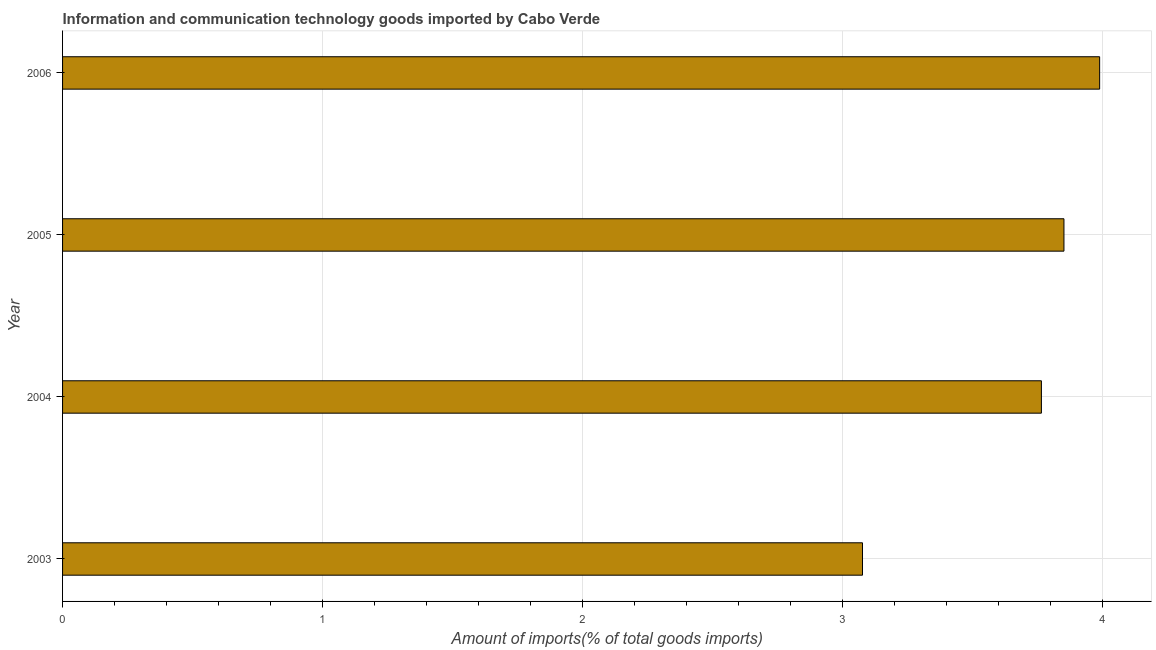Does the graph contain any zero values?
Ensure brevity in your answer.  No. What is the title of the graph?
Provide a succinct answer. Information and communication technology goods imported by Cabo Verde. What is the label or title of the X-axis?
Your answer should be compact. Amount of imports(% of total goods imports). What is the amount of ict goods imports in 2004?
Make the answer very short. 3.76. Across all years, what is the maximum amount of ict goods imports?
Provide a short and direct response. 3.99. Across all years, what is the minimum amount of ict goods imports?
Provide a short and direct response. 3.08. In which year was the amount of ict goods imports minimum?
Your response must be concise. 2003. What is the sum of the amount of ict goods imports?
Your response must be concise. 14.68. What is the difference between the amount of ict goods imports in 2003 and 2005?
Your answer should be very brief. -0.78. What is the average amount of ict goods imports per year?
Provide a succinct answer. 3.67. What is the median amount of ict goods imports?
Keep it short and to the point. 3.81. In how many years, is the amount of ict goods imports greater than 3.2 %?
Ensure brevity in your answer.  3. What is the ratio of the amount of ict goods imports in 2003 to that in 2005?
Ensure brevity in your answer.  0.8. Is the difference between the amount of ict goods imports in 2003 and 2005 greater than the difference between any two years?
Provide a short and direct response. No. What is the difference between the highest and the second highest amount of ict goods imports?
Your response must be concise. 0.14. What is the difference between the highest and the lowest amount of ict goods imports?
Make the answer very short. 0.91. Are all the bars in the graph horizontal?
Keep it short and to the point. Yes. What is the Amount of imports(% of total goods imports) of 2003?
Your response must be concise. 3.08. What is the Amount of imports(% of total goods imports) of 2004?
Give a very brief answer. 3.76. What is the Amount of imports(% of total goods imports) in 2005?
Your answer should be very brief. 3.85. What is the Amount of imports(% of total goods imports) of 2006?
Provide a succinct answer. 3.99. What is the difference between the Amount of imports(% of total goods imports) in 2003 and 2004?
Your answer should be compact. -0.69. What is the difference between the Amount of imports(% of total goods imports) in 2003 and 2005?
Make the answer very short. -0.77. What is the difference between the Amount of imports(% of total goods imports) in 2003 and 2006?
Ensure brevity in your answer.  -0.91. What is the difference between the Amount of imports(% of total goods imports) in 2004 and 2005?
Your response must be concise. -0.09. What is the difference between the Amount of imports(% of total goods imports) in 2004 and 2006?
Provide a succinct answer. -0.22. What is the difference between the Amount of imports(% of total goods imports) in 2005 and 2006?
Keep it short and to the point. -0.14. What is the ratio of the Amount of imports(% of total goods imports) in 2003 to that in 2004?
Make the answer very short. 0.82. What is the ratio of the Amount of imports(% of total goods imports) in 2003 to that in 2005?
Keep it short and to the point. 0.8. What is the ratio of the Amount of imports(% of total goods imports) in 2003 to that in 2006?
Your response must be concise. 0.77. What is the ratio of the Amount of imports(% of total goods imports) in 2004 to that in 2005?
Your answer should be very brief. 0.98. What is the ratio of the Amount of imports(% of total goods imports) in 2004 to that in 2006?
Make the answer very short. 0.94. 